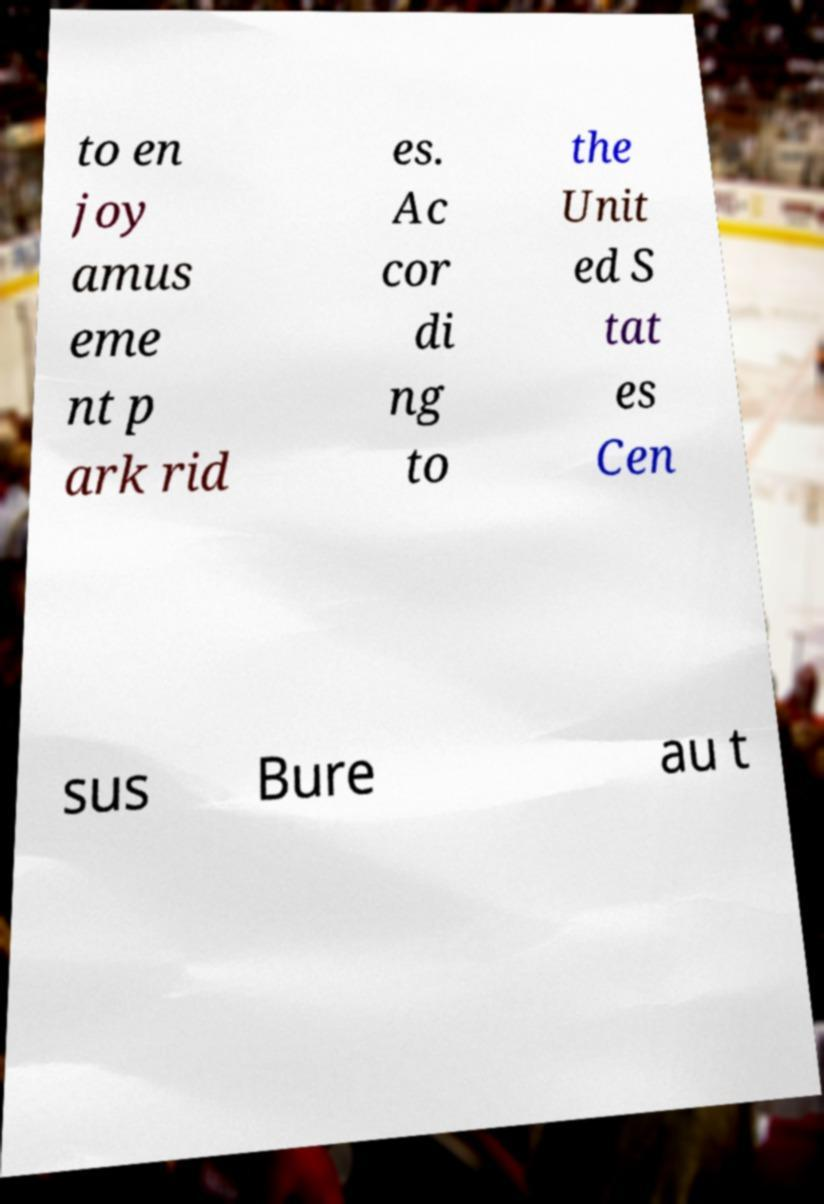Please read and relay the text visible in this image. What does it say? to en joy amus eme nt p ark rid es. Ac cor di ng to the Unit ed S tat es Cen sus Bure au t 